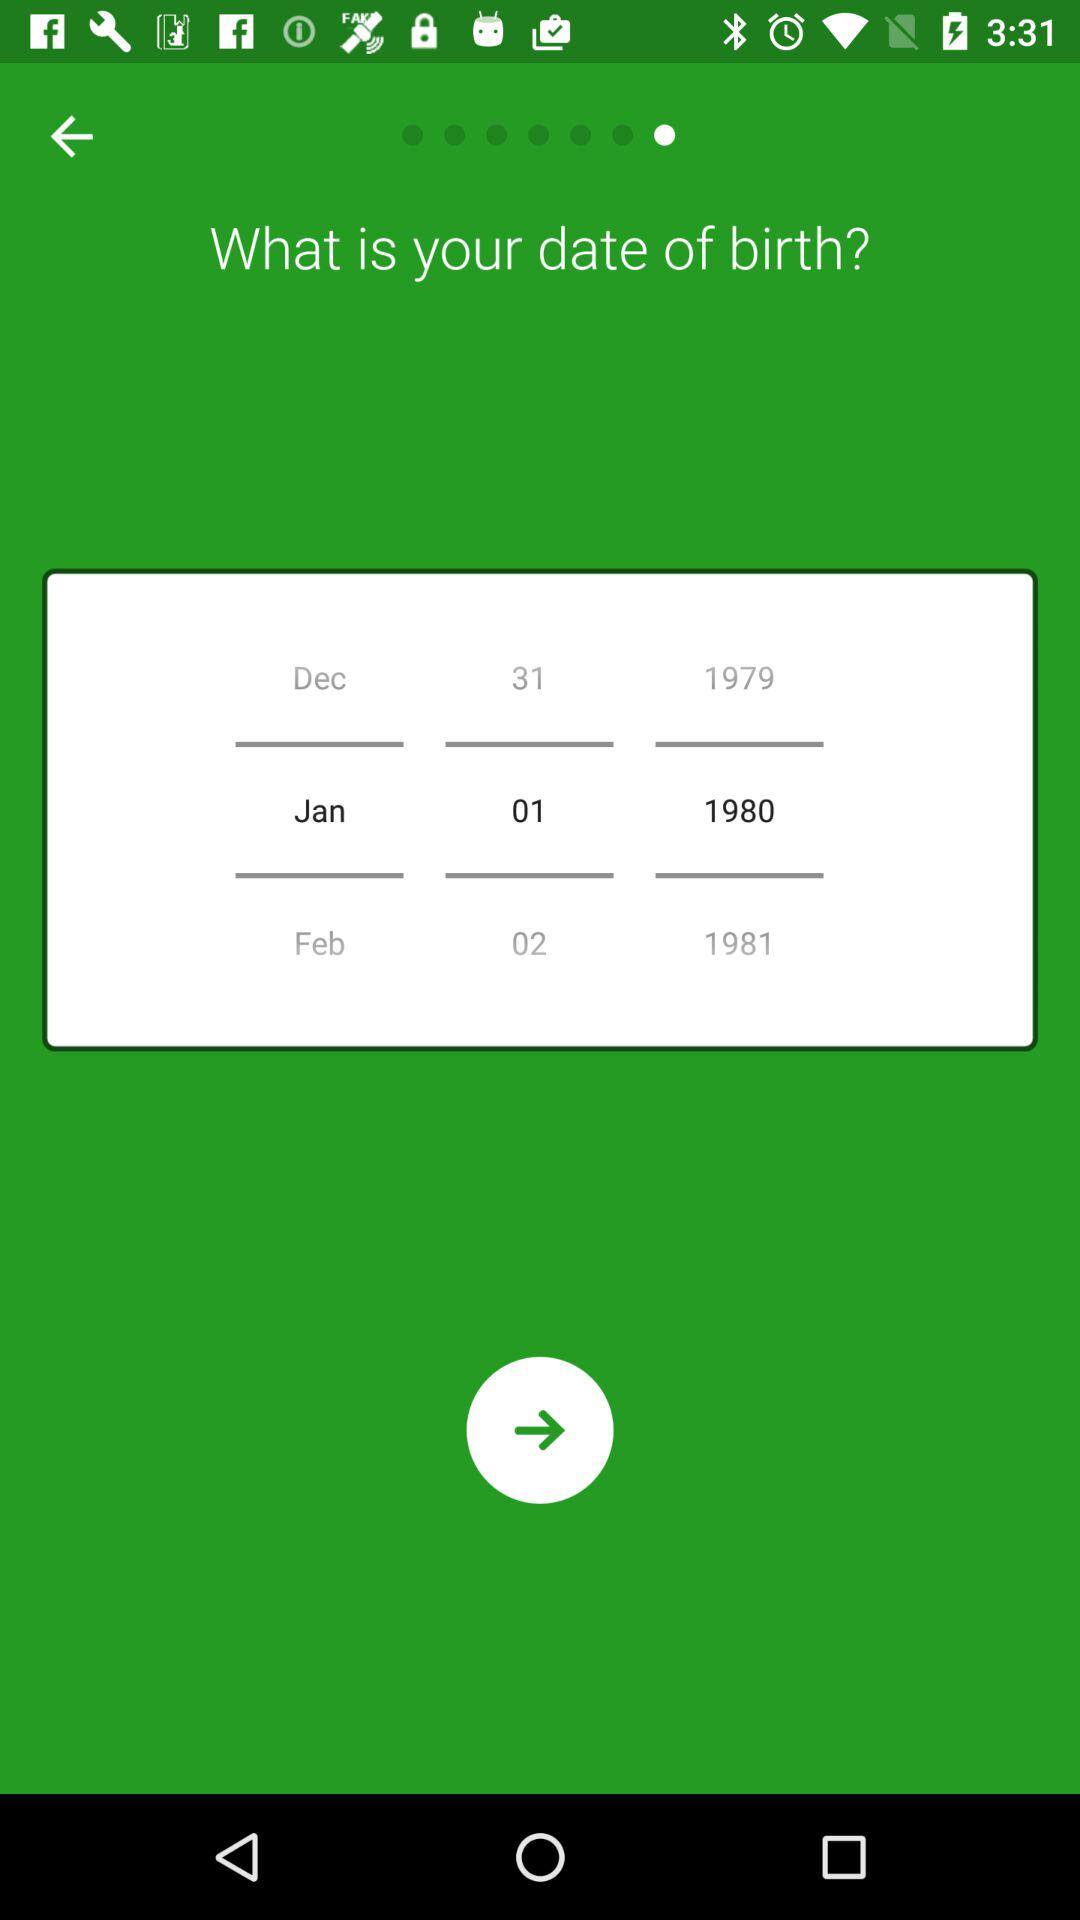How many years between the earliest and latest birth dates displayed?
Answer the question using a single word or phrase. 2 